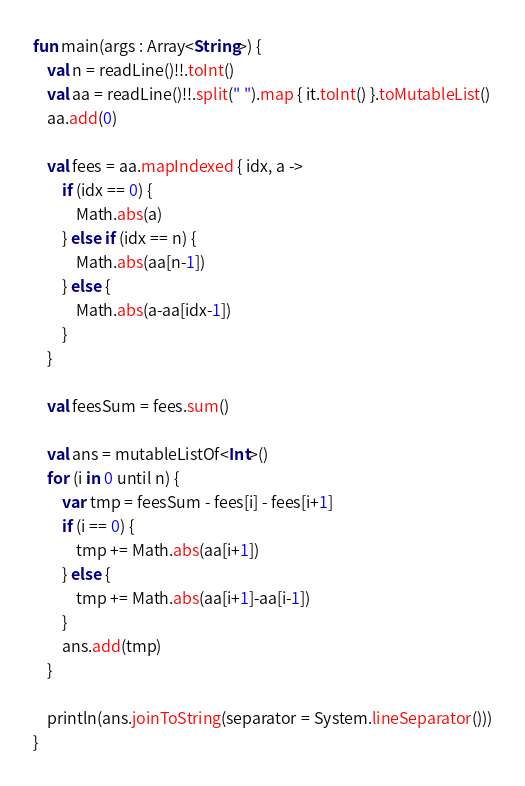<code> <loc_0><loc_0><loc_500><loc_500><_Kotlin_>fun main(args : Array<String>) {
    val n = readLine()!!.toInt()
    val aa = readLine()!!.split(" ").map { it.toInt() }.toMutableList()
    aa.add(0)

    val fees = aa.mapIndexed { idx, a ->
        if (idx == 0) {
            Math.abs(a)
        } else if (idx == n) {
            Math.abs(aa[n-1])
        } else {
            Math.abs(a-aa[idx-1])
        }
    }

    val feesSum = fees.sum()

    val ans = mutableListOf<Int>()
    for (i in 0 until n) {
        var tmp = feesSum - fees[i] - fees[i+1]
        if (i == 0) {
            tmp += Math.abs(aa[i+1])
        } else {
            tmp += Math.abs(aa[i+1]-aa[i-1])
        }
        ans.add(tmp)
    }

    println(ans.joinToString(separator = System.lineSeparator()))
}</code> 